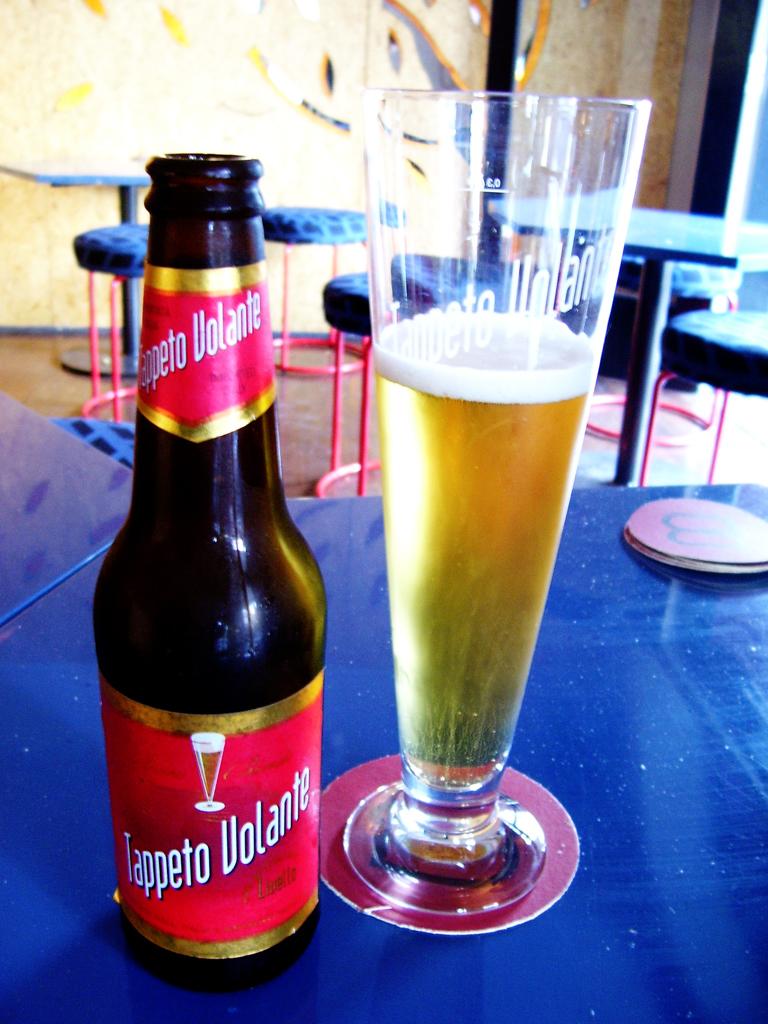What kind of beer is that?
Provide a short and direct response. Tappeto volante. What is the first letter of the second word on the glass?
Give a very brief answer. V. 